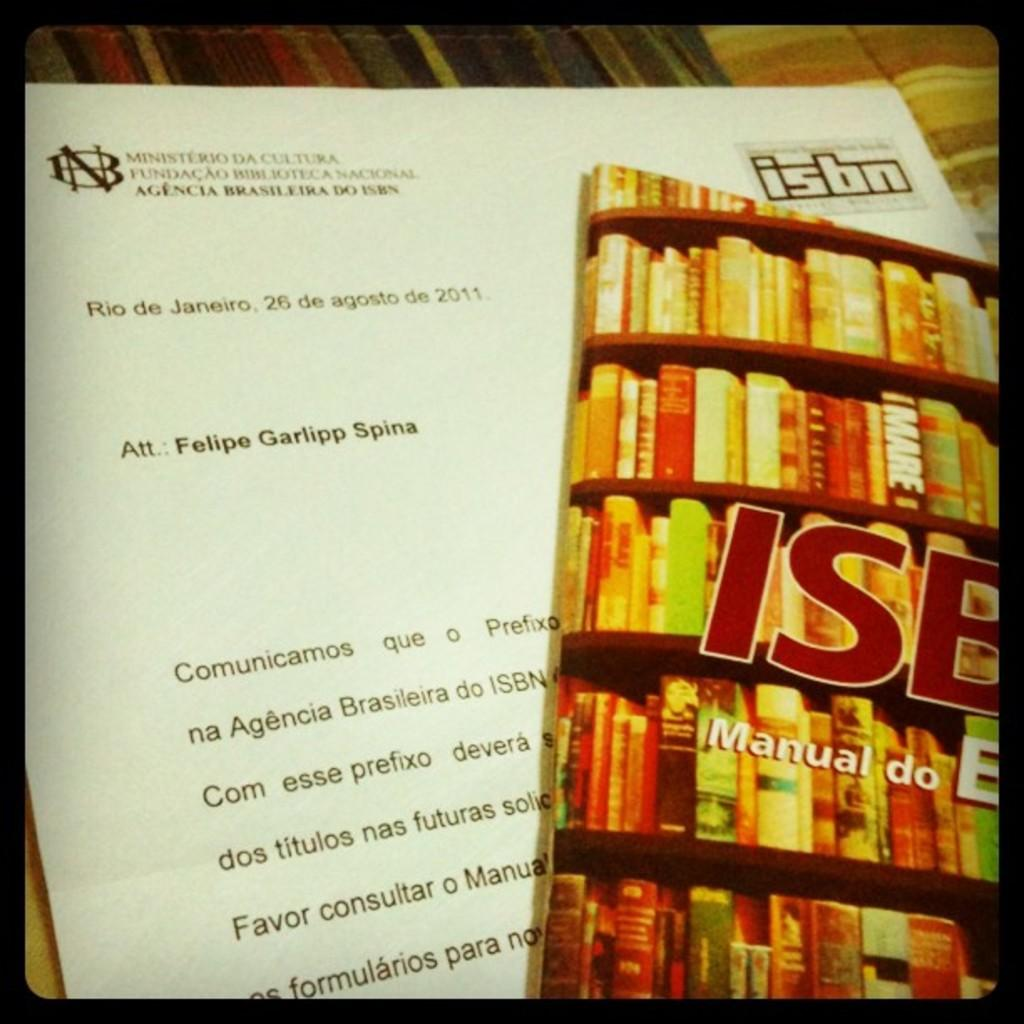Provide a one-sentence caption for the provided image. a letter and book about ISBN att: Felipe. 